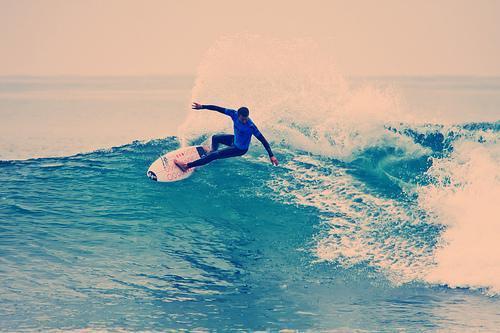How many surfers are in the picture?
Give a very brief answer. 1. 